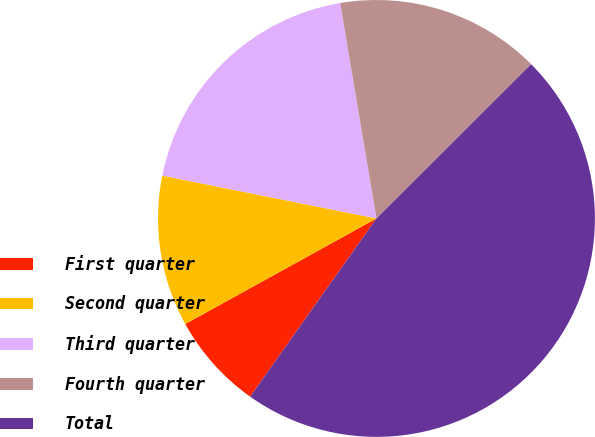Convert chart. <chart><loc_0><loc_0><loc_500><loc_500><pie_chart><fcel>First quarter<fcel>Second quarter<fcel>Third quarter<fcel>Fourth quarter<fcel>Total<nl><fcel>7.16%<fcel>11.17%<fcel>19.2%<fcel>15.18%<fcel>47.29%<nl></chart> 